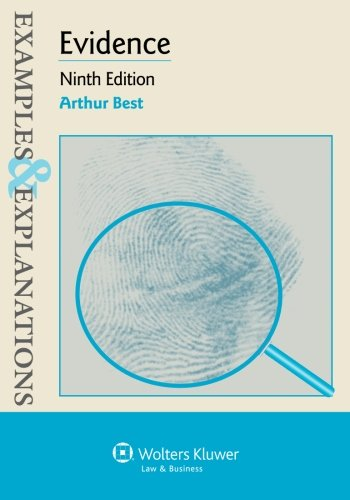Is this a transportation engineering book? No, this book pertains strictly to the field of law, emphasizing on evidence in legal contexts, and does not cover transportation engineering. 